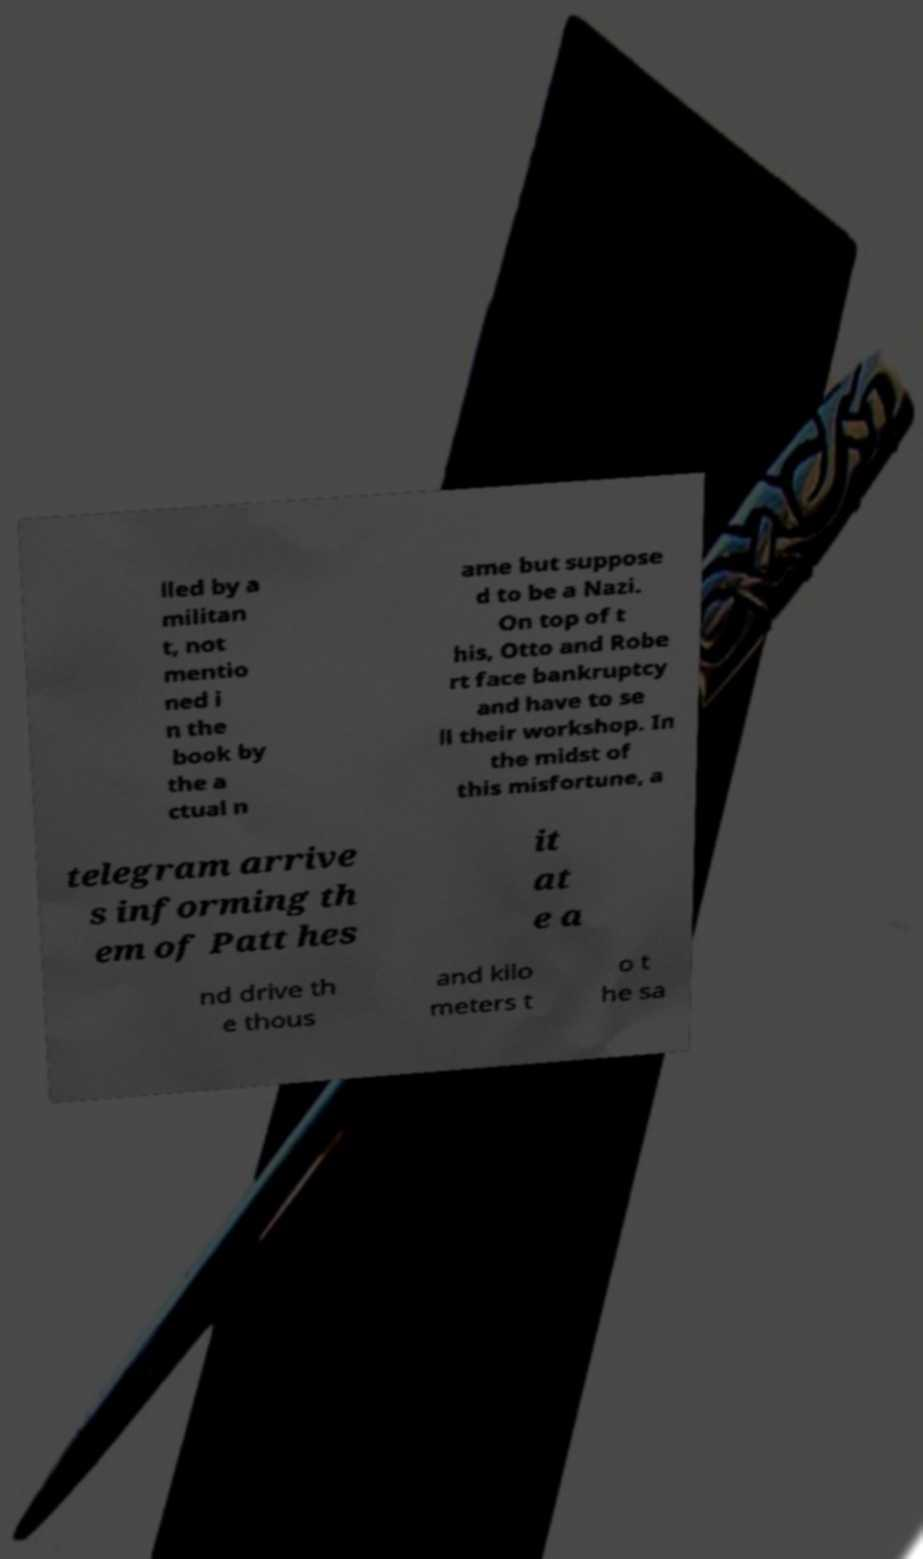What messages or text are displayed in this image? I need them in a readable, typed format. lled by a militan t, not mentio ned i n the book by the a ctual n ame but suppose d to be a Nazi. On top of t his, Otto and Robe rt face bankruptcy and have to se ll their workshop. In the midst of this misfortune, a telegram arrive s informing th em of Patt hes it at e a nd drive th e thous and kilo meters t o t he sa 